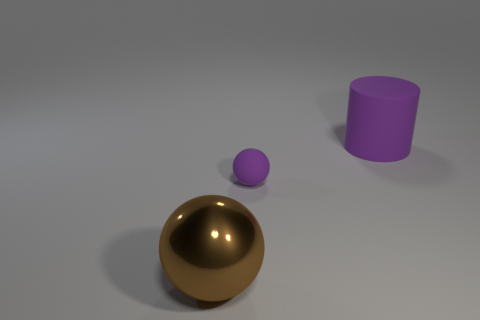Is there anything else that is the same size as the rubber sphere?
Offer a very short reply. No. Does the large matte thing have the same color as the matte sphere?
Give a very brief answer. Yes. There is a thing that is to the left of the purple matte cylinder and behind the large shiny sphere; what is its color?
Offer a terse response. Purple. What is the large thing that is on the left side of the small purple rubber ball made of?
Offer a terse response. Metal. The purple rubber sphere has what size?
Provide a short and direct response. Small. What number of blue things are matte things or metal objects?
Your answer should be compact. 0. There is a purple matte object to the left of the large thing that is on the right side of the brown shiny object; how big is it?
Your answer should be compact. Small. Is the color of the matte ball the same as the object to the right of the tiny purple matte ball?
Ensure brevity in your answer.  Yes. What number of other things are there of the same material as the large ball
Provide a succinct answer. 0. What is the shape of the large purple thing that is the same material as the purple ball?
Your answer should be compact. Cylinder. 